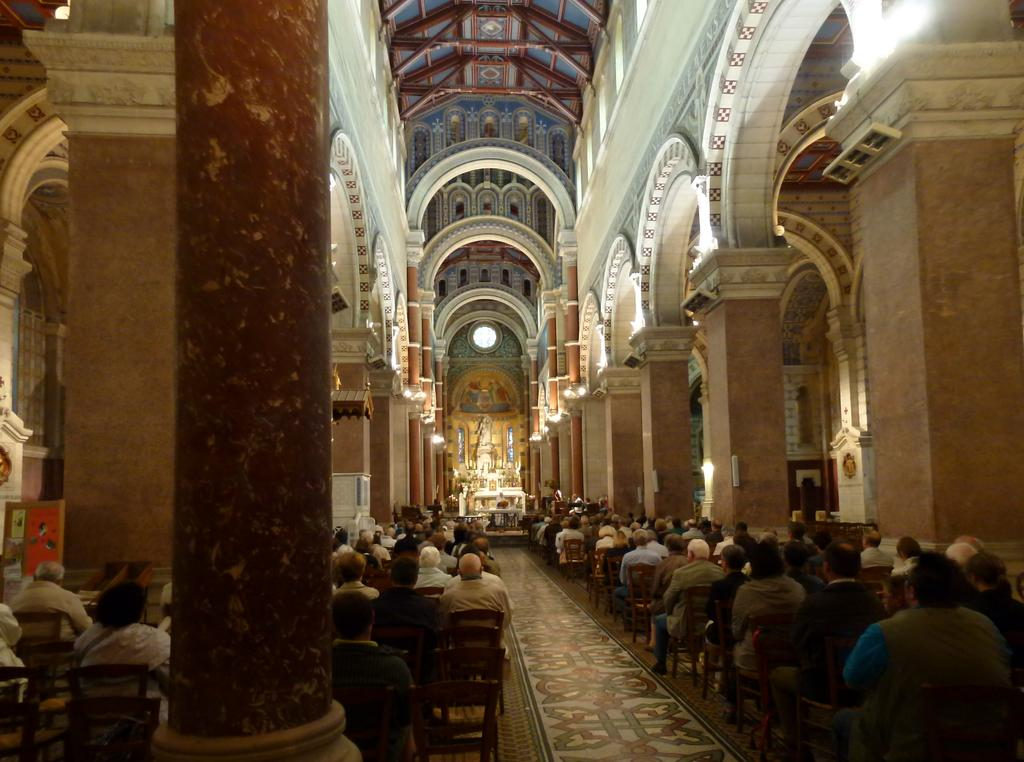Where was the image taken? The image was taken in a hall. What can be seen in the center of the image? There are people sitting in the center of the image. What is visible in the image that provides illumination? There are lights visible in the image. What is at the top of the image? There is a roof at the top of the image. What type of badge is being worn by the cabbage in the image? There is no cabbage or badge present in the image. 